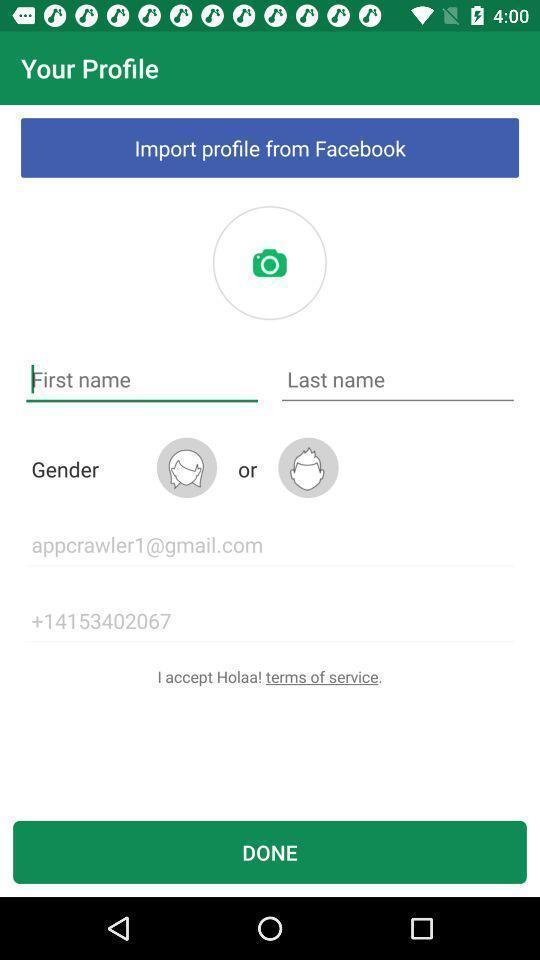What can you discern from this picture? Page displaying to enter the profile details with done option. 